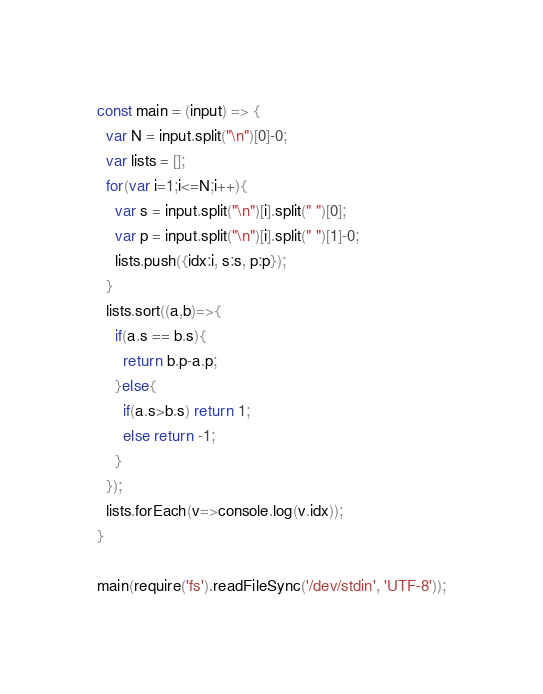<code> <loc_0><loc_0><loc_500><loc_500><_JavaScript_>const main = (input) => {
  var N = input.split("\n")[0]-0;
  var lists = [];
  for(var i=1;i<=N;i++){
    var s = input.split("\n")[i].split(" ")[0];
    var p = input.split("\n")[i].split(" ")[1]-0;
    lists.push({idx:i, s:s, p:p});
  }
  lists.sort((a,b)=>{
    if(a.s == b.s){
      return b.p-a.p;
    }else{
      if(a.s>b.s) return 1;
      else return -1;
    }
  });
  lists.forEach(v=>console.log(v.idx));
}

main(require('fs').readFileSync('/dev/stdin', 'UTF-8'));
</code> 